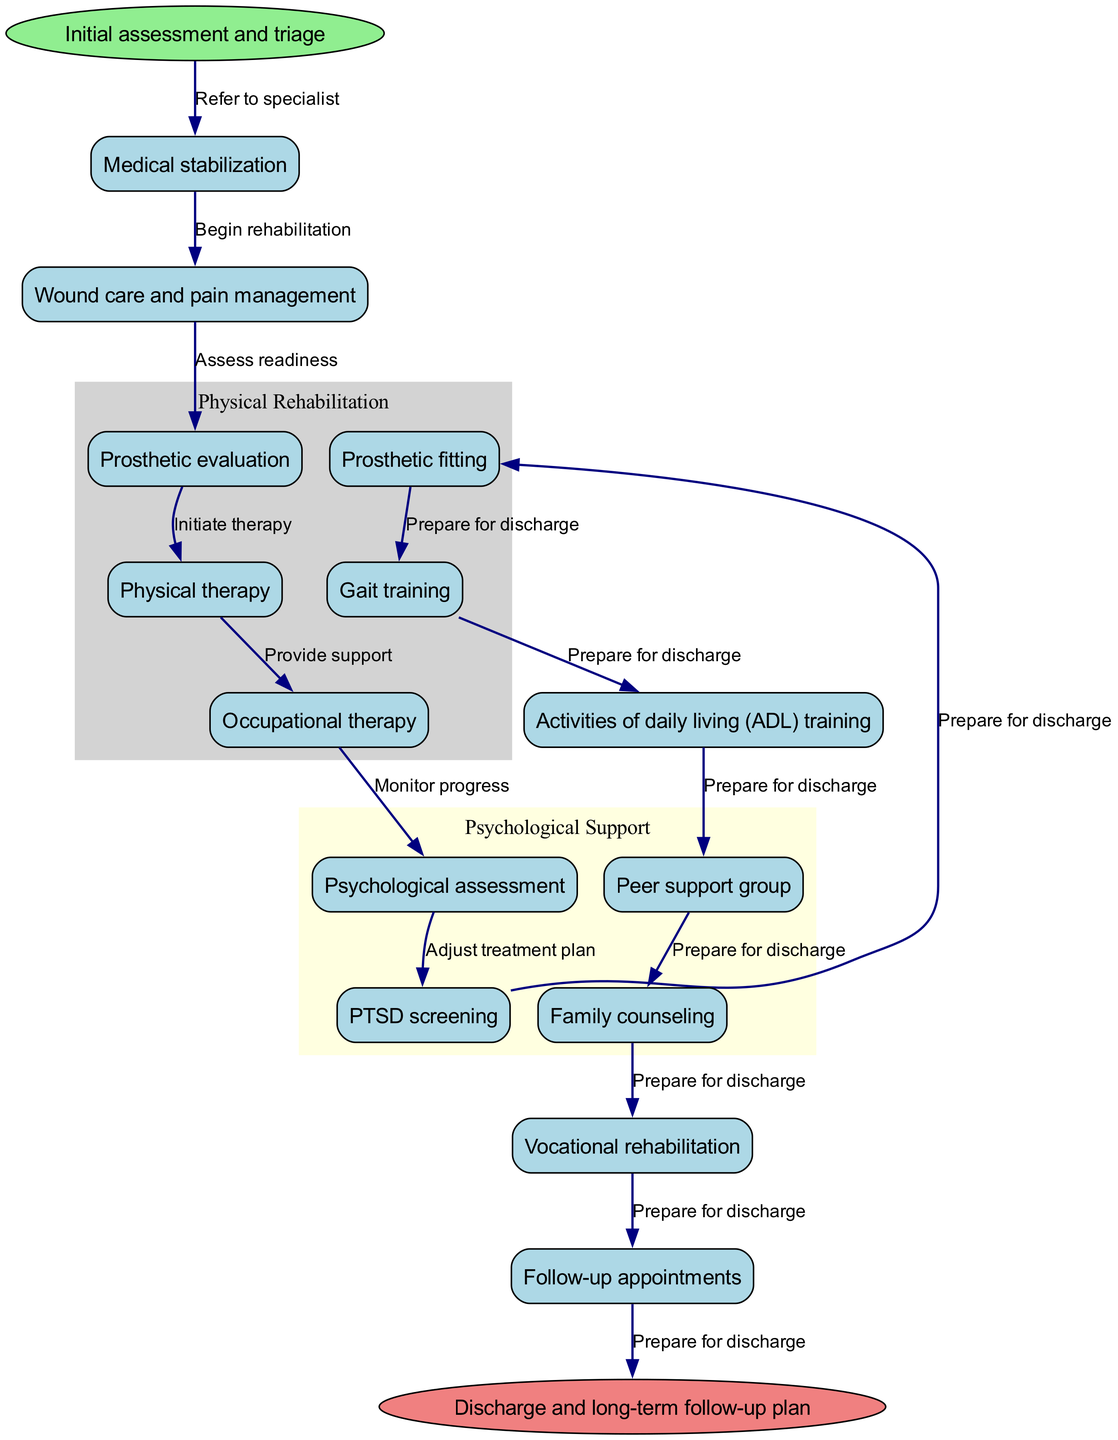What is the first step in the clinical pathway? The diagram indicates that the first step in the clinical pathway is "Initial assessment and triage." This is represented as the starting point of the pathway, leading to all subsequent steps.
Answer: Initial assessment and triage How many nodes are in the diagram? By counting the listed nodes in the pathway, there are a total of 14 nodes that represent various steps and components in the rehabilitation process for amputees.
Answer: 14 What follows "Wound care and pain management"? According to the diagram, the next step after "Wound care and pain management" is "Prosthetic evaluation." This shows the chronological order of the rehabilitation process.
Answer: Prosthetic evaluation What type of therapies are included in the physical rehabilitation phase? The diagram clusters several therapies under the "Physical Rehabilitation" category, which includes "Prosthetic evaluation," "Physical therapy," "Occupational therapy," and "Gait training."
Answer: Prosthetic evaluation, Physical therapy, Occupational therapy, Gait training How many edges connect "Psychological assessment" to other nodes? "Psychological assessment" has two edges connecting it to "PTSD screening" and "Peer support group," indicating two pathways of support related to mental health in the rehabilitation process.
Answer: 2 What step comes before "Activities of daily living (ADL) training"? The diagram shows that the step prior to "Activities of daily living (ADL) training" is "Gait training," highlighting the sequence in which rehabilitation skills are developed.
Answer: Gait training What is the last step in the clinical pathway? The diagram indicates that the final step in the clinical pathway is "Discharge and long-term follow-up plan," which signifies the conclusion of the active rehabilitation program.
Answer: Discharge and long-term follow-up plan Which two nodes are connected by the edge labeled "Prepare for discharge"? The edge labeled "Prepare for discharge" connects the "Vocational rehabilitation" node and the "end" node, which is "Discharge and long-term follow-up plan." This indicates that vocational rehabilitation is the last phase before discharge.
Answer: Vocational rehabilitation and Discharge and long-term follow-up plan What type of support is provided besides psychological assessment? According to the diagram, in addition to "Psychological assessment," there is "Family counseling," and "Peer support group," indicating a well-rounded approach to psychological support for amputees.
Answer: Family counseling and Peer support group 